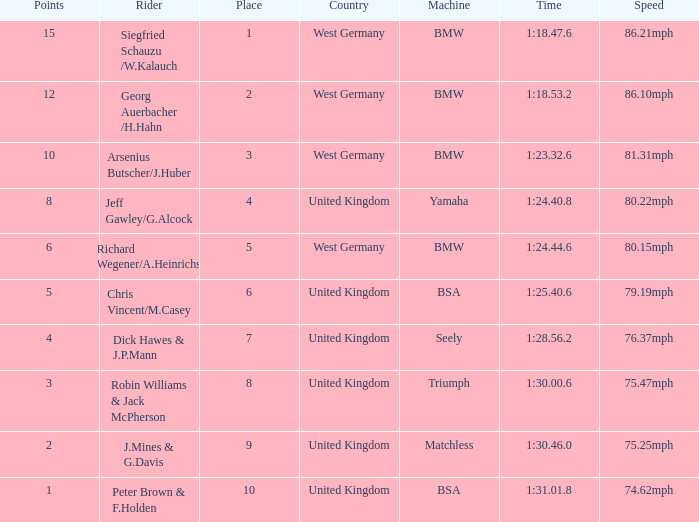Which place has points larger than 1, a bmw machine, and a time of 1:18.47.6? 1.0. 